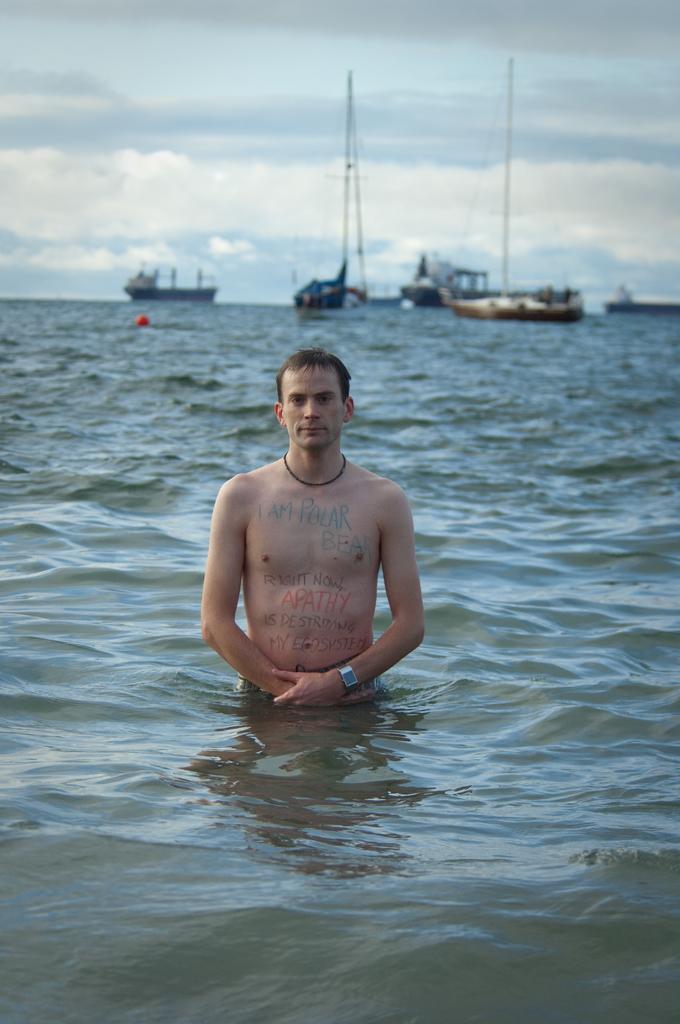In one or two sentences, can you explain what this image depicts? In this image a person is standing in the water body. In the background there are ships. The sky is cloudy. On the man's body there are few texts are there. 